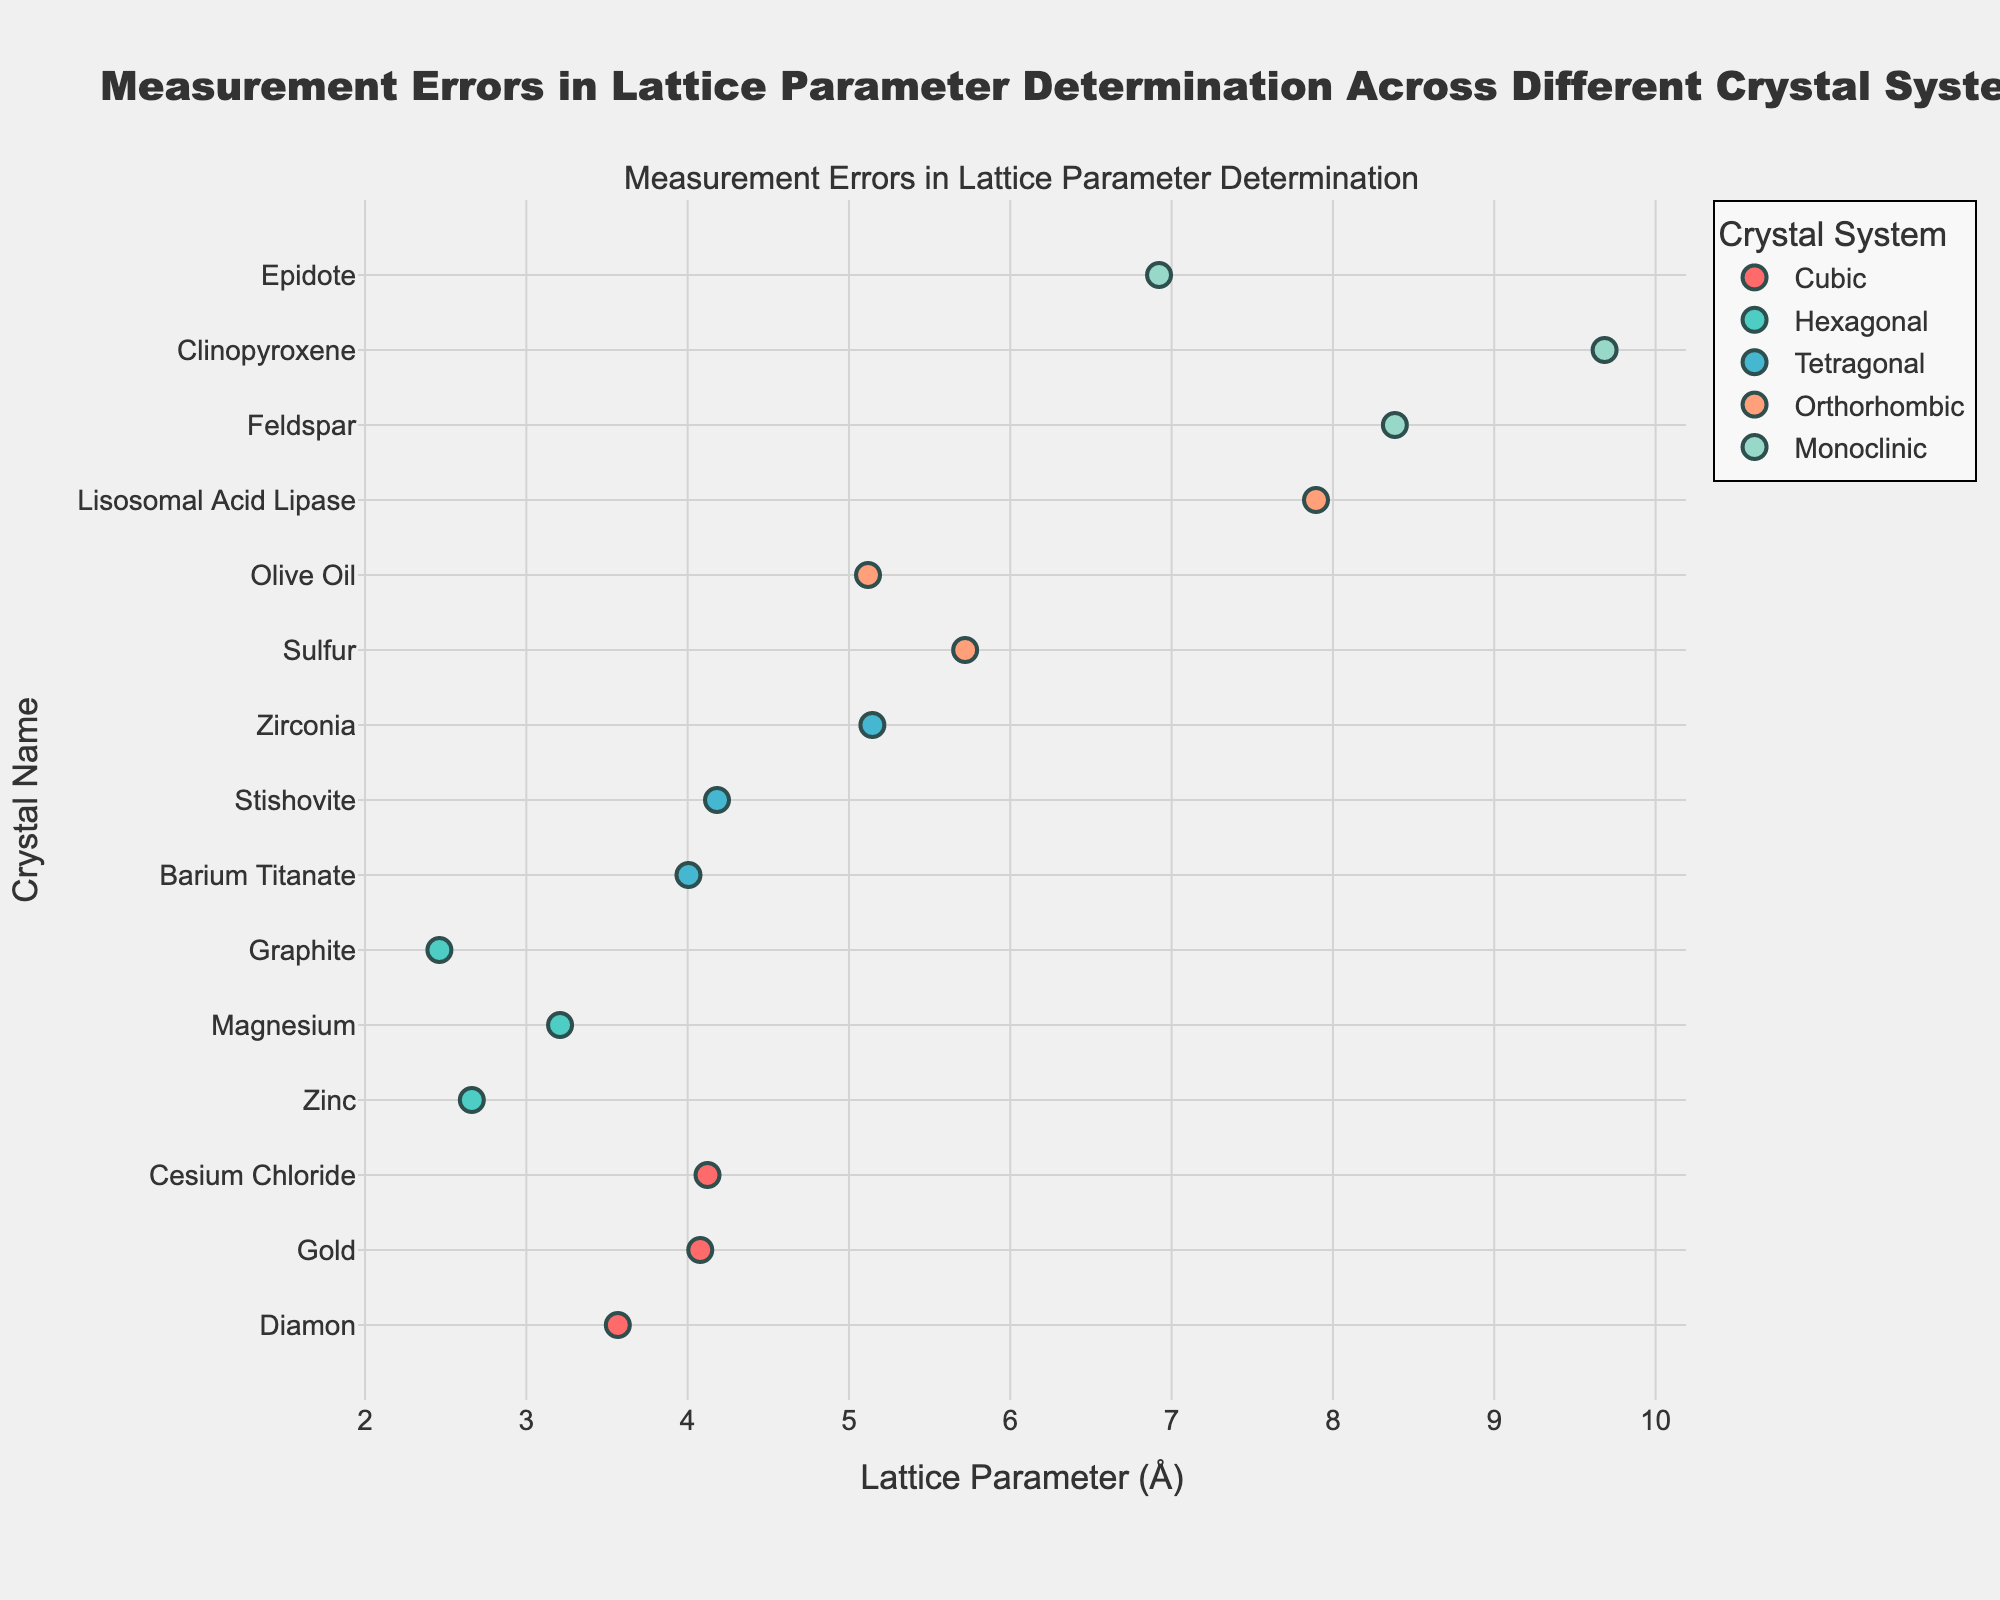what is the title of the plot? The title is located at the top of the plot, denoted by the largest font size. It describes the context and subject of the visualized data.
Answer: Measurement Errors in Lattice Parameter Determination Across Different Crystal Systems How many crystal systems are represented in the plot? The distinct crystal systems are represented by different colors and are listed in the legend box. Each unique entry in the legend corresponds to a different crystal system.
Answer: Four Which crystal system has the highest measurement error? Look for the longest error bar among all data points. Identify which crystal system this occurrence belongs to by checking the color or the crystal name.
Answer: Monoclinic (Clinopyroxene) What is the general range of the lattice parameter values for cubic crystal systems? Scan the x-axis values (lattice parameter) for all dots marked with the same color representing cubic systems. Observe the lowest and highest values.
Answer: 3.567 to 4.123 Which crystal system appears to have the most measurement errors for its data points? Identify the crystal system with the largest number of data points. This can quickly be observed by counting the dots associated with each color.
Answer: Cubic What is the lattice parameter of the crystal with the smallest measurement error? Locate the shortest error bar and note its position on the x-axis, then match it to its corresponding y-axis label.
Answer: 3.567 (Diamond) Which two crystals have the largest difference in lattice parameters within the same system? Trace within one system (same color) to find the maximum and minimum lattice parameter values. Compute their difference and observe for each system.
Answer: Monoclinic (Clinopyroxene and Epidote, difference = 9.684 - 6.922 = 2.762) Compare the average measurement error between tetragonal and orthorhombic crystal systems. Which is higher? Calculate the average measurement error for each system by summing and dividing by their count. Compare these averages.
Answer: Orthorhombic What are the lattice parameters and corresponding measurement errors for all hexagonal crystals? Identify all dots of the color representing hexagonal crystals and read off their x-axis values and the lengths of their error bars.
Answer: Zinc (2.662, 0.003), Magnesium (3.209, 0.0025), Graphite (2.461, 0.004) What's the crystal with the highest lattice parameter? Look at the extreme right side of the x-axis and identify which crystal label aligns with the highest value.
Answer: Monoclinic (Clinopyroxene) 